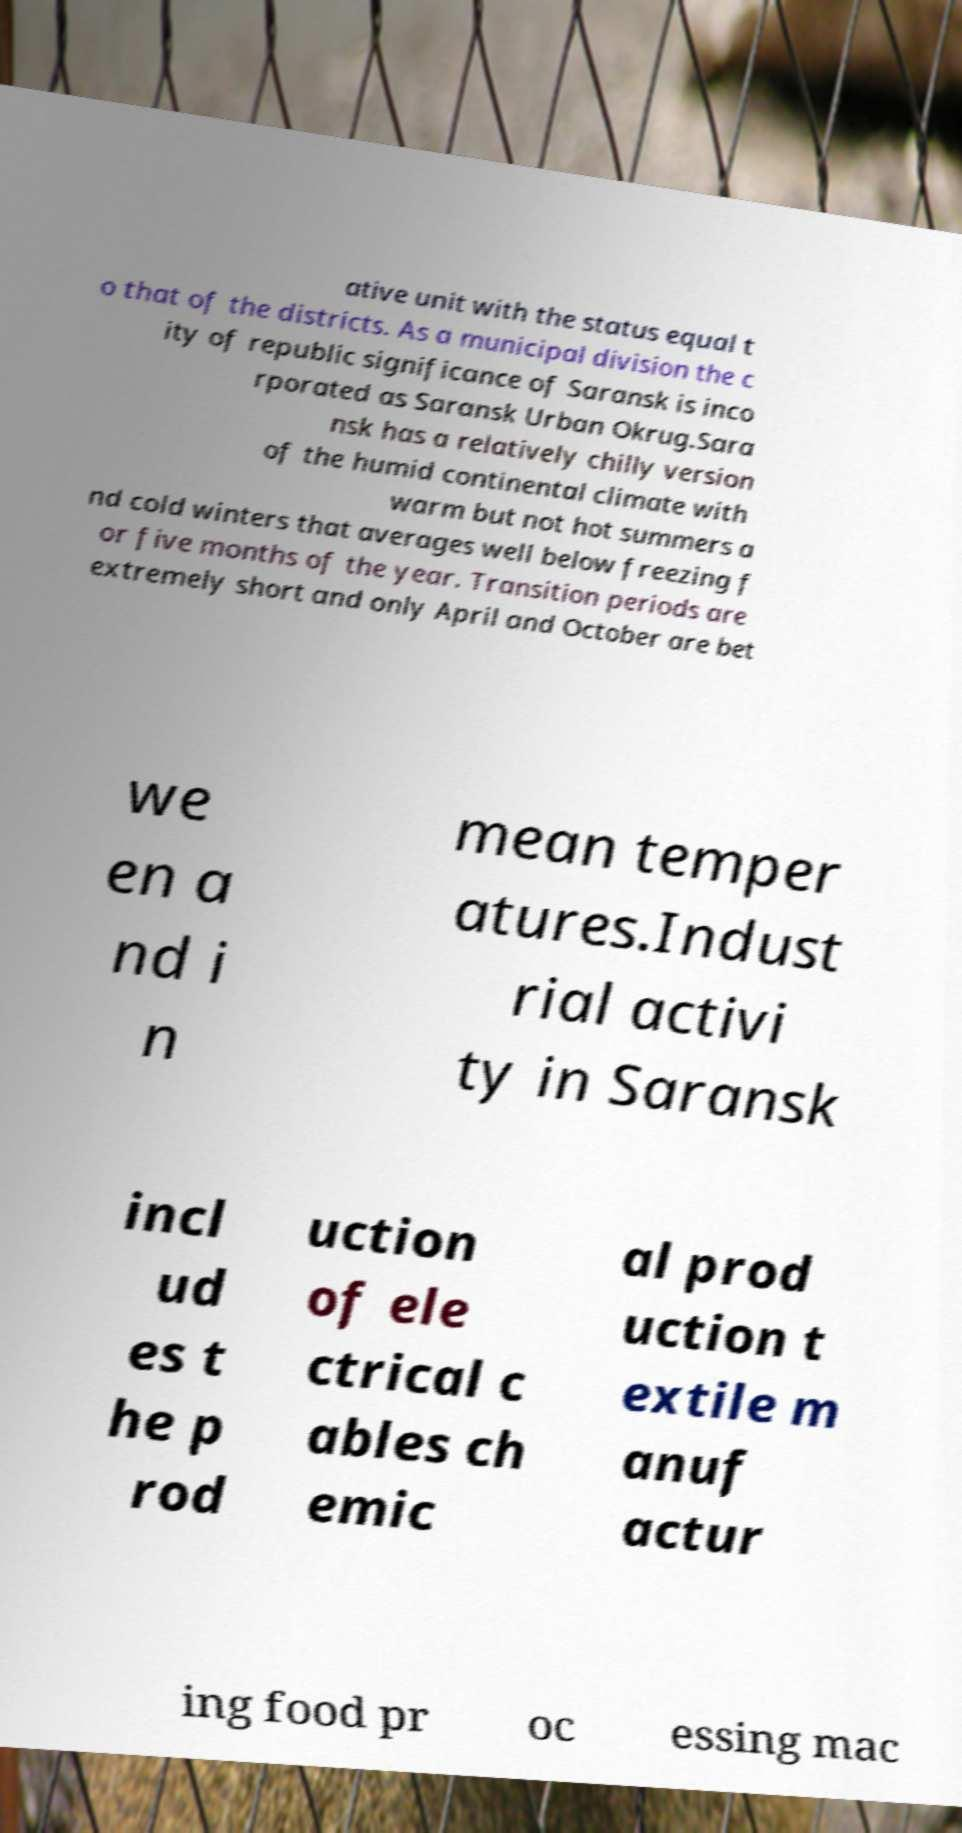Please identify and transcribe the text found in this image. ative unit with the status equal t o that of the districts. As a municipal division the c ity of republic significance of Saransk is inco rporated as Saransk Urban Okrug.Sara nsk has a relatively chilly version of the humid continental climate with warm but not hot summers a nd cold winters that averages well below freezing f or five months of the year. Transition periods are extremely short and only April and October are bet we en a nd i n mean temper atures.Indust rial activi ty in Saransk incl ud es t he p rod uction of ele ctrical c ables ch emic al prod uction t extile m anuf actur ing food pr oc essing mac 